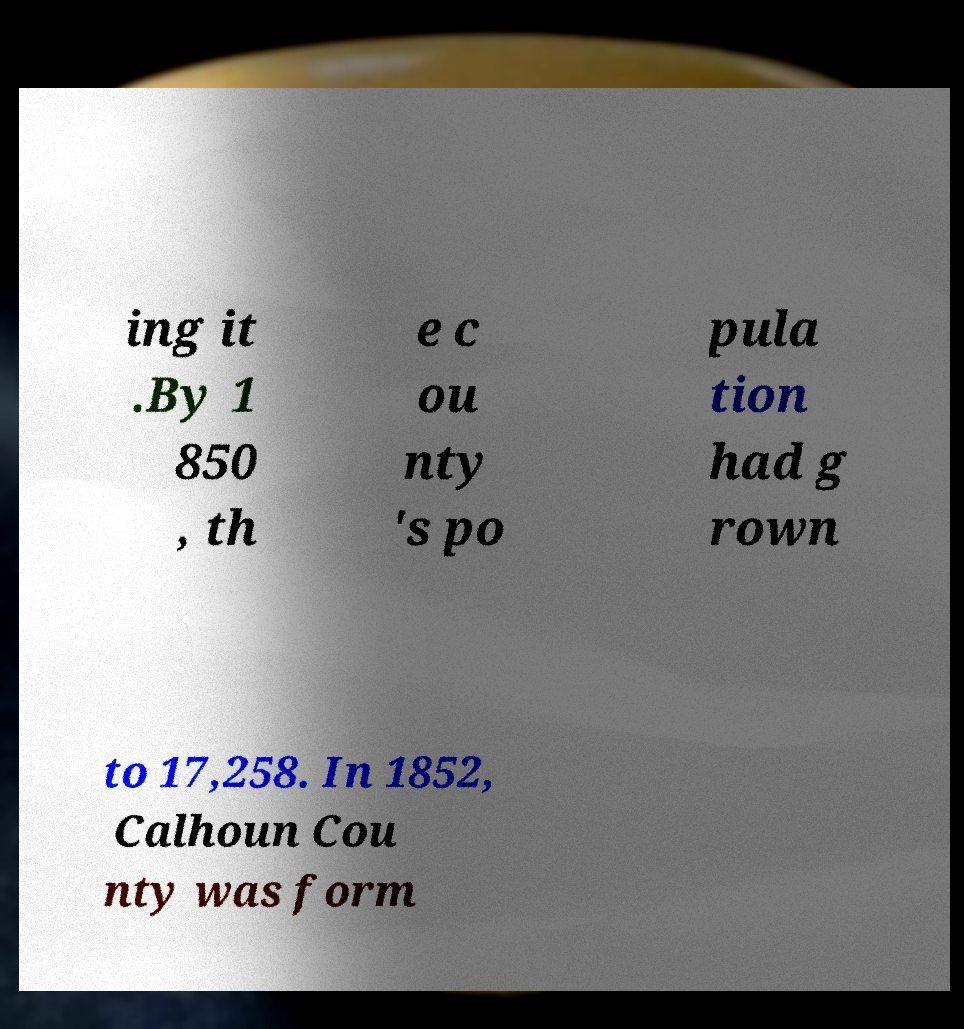Could you assist in decoding the text presented in this image and type it out clearly? ing it .By 1 850 , th e c ou nty 's po pula tion had g rown to 17,258. In 1852, Calhoun Cou nty was form 